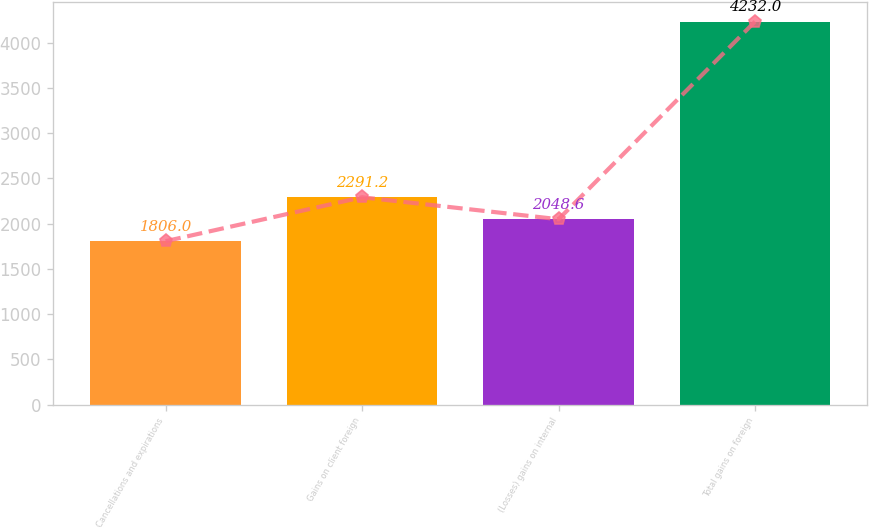Convert chart to OTSL. <chart><loc_0><loc_0><loc_500><loc_500><bar_chart><fcel>Cancellations and expirations<fcel>Gains on client foreign<fcel>(Losses) gains on internal<fcel>Total gains on foreign<nl><fcel>1806<fcel>2291.2<fcel>2048.6<fcel>4232<nl></chart> 